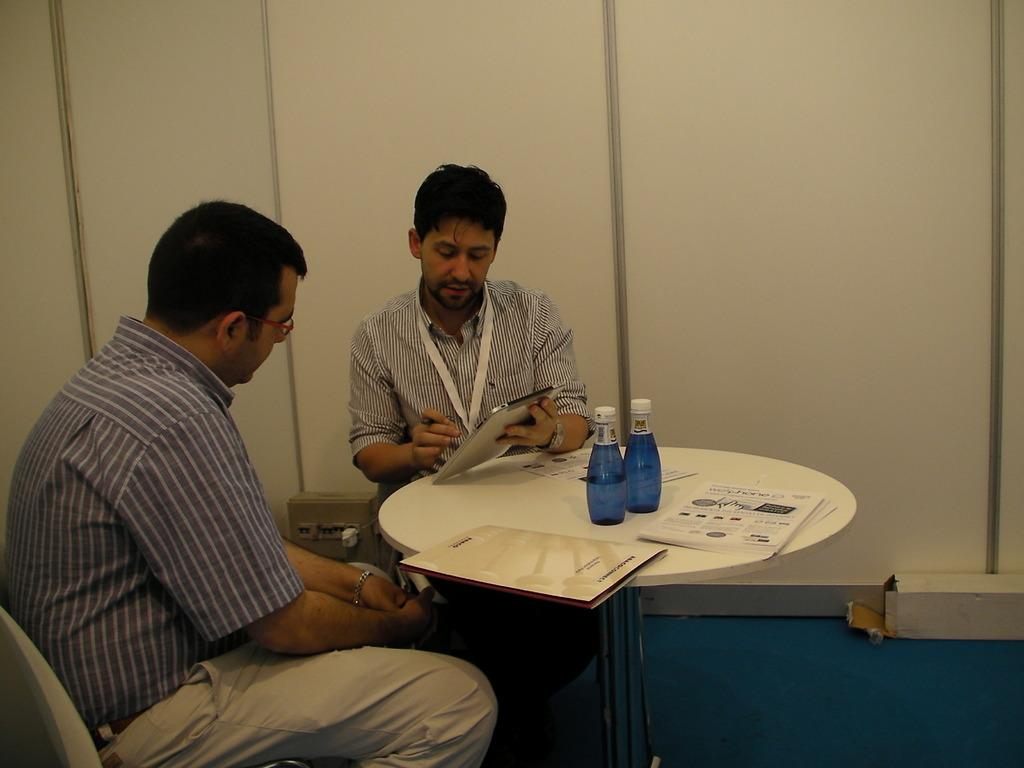What objects can be seen on the table in the image? There are bottles, papers, and a file on the table in the image. What is the man holding in his hand? The man is holding a gadget in his hand. What is the man doing in the image? The man is explaining something to another person. What can be seen on the man's face? The man is wearing spectacles. What type of surface is the table and the man on? This is a floor. How many matches are on the table in the image? There are no matches present on the table in the image. What type of pest can be seen crawling on the man's shoulder in the image? There are no pests visible on the man's shoulder or anywhere else in the image. 